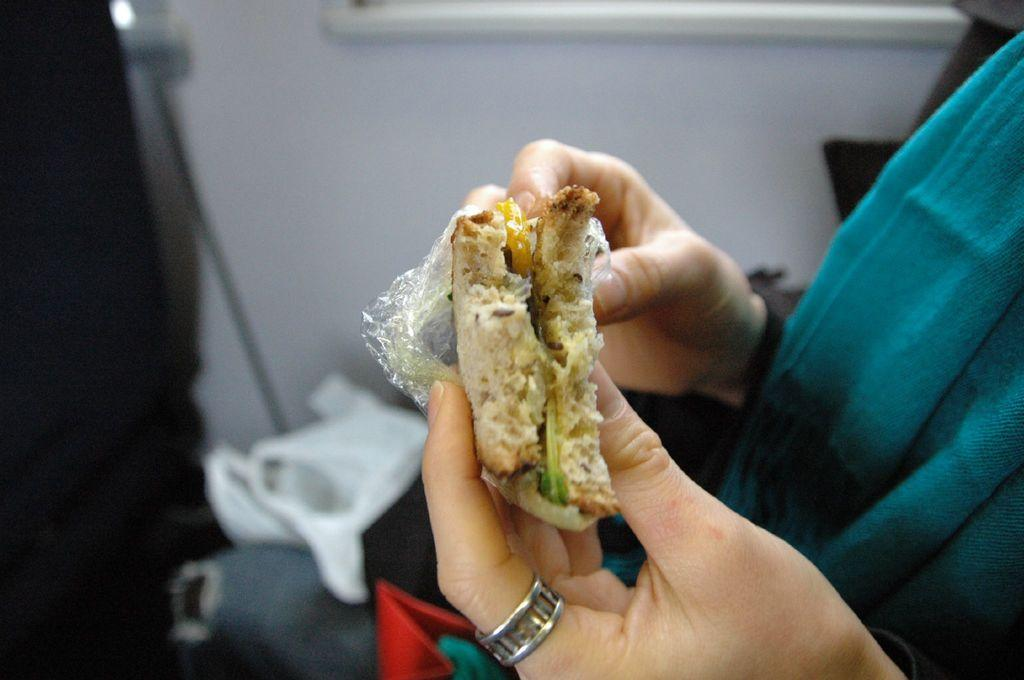Who is present in the image? There is a person in the image. What is the person holding in their hands? The person is holding a sandwich in their hands. What can be seen in the background of the image? There are bags and polythene covers in the background of the image. What type of club does the person belong to in the image? There is no indication of a club or any affiliation in the image; it simply shows a person holding a sandwich. 